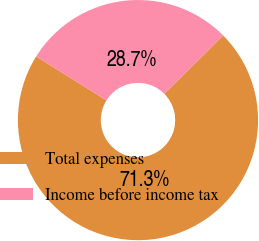Convert chart. <chart><loc_0><loc_0><loc_500><loc_500><pie_chart><fcel>Total expenses<fcel>Income before income tax<nl><fcel>71.34%<fcel>28.66%<nl></chart> 